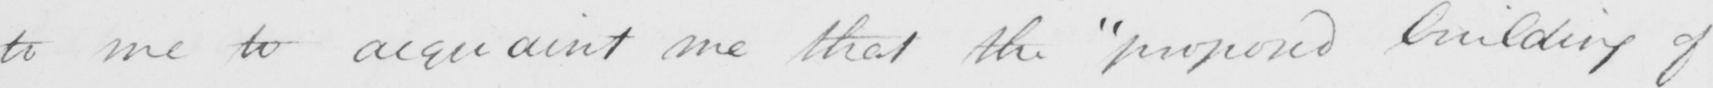Can you read and transcribe this handwriting? to me to acquaint me that the  " proposed building of 